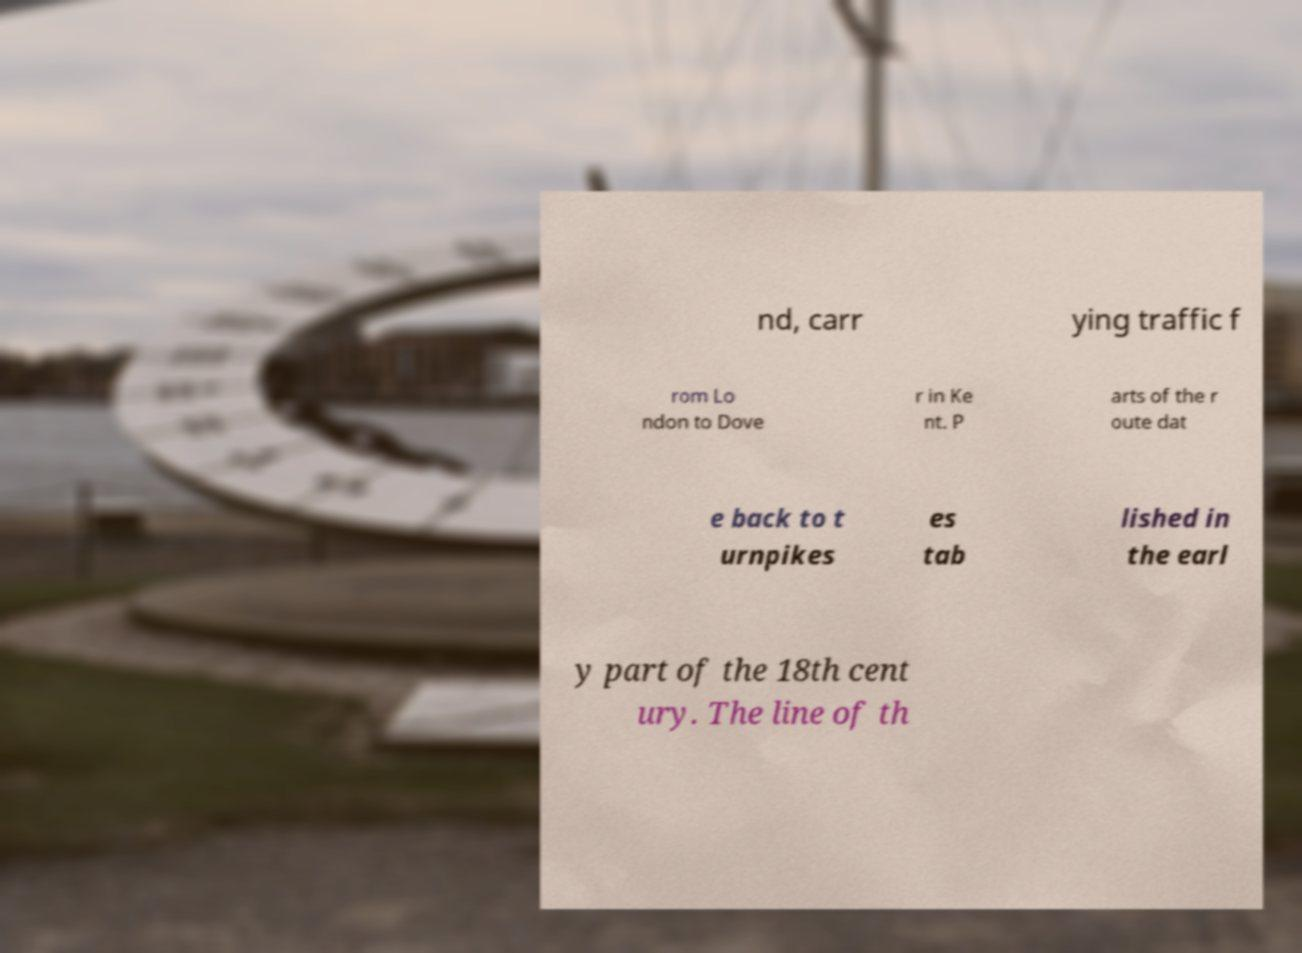There's text embedded in this image that I need extracted. Can you transcribe it verbatim? nd, carr ying traffic f rom Lo ndon to Dove r in Ke nt. P arts of the r oute dat e back to t urnpikes es tab lished in the earl y part of the 18th cent ury. The line of th 